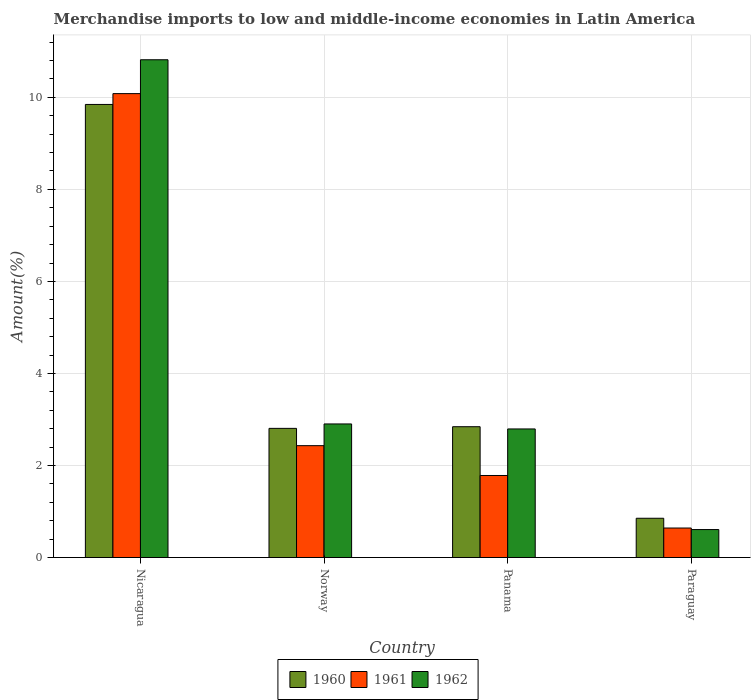How many bars are there on the 1st tick from the right?
Keep it short and to the point. 3. What is the label of the 1st group of bars from the left?
Offer a terse response. Nicaragua. What is the percentage of amount earned from merchandise imports in 1961 in Nicaragua?
Your response must be concise. 10.08. Across all countries, what is the maximum percentage of amount earned from merchandise imports in 1961?
Ensure brevity in your answer.  10.08. Across all countries, what is the minimum percentage of amount earned from merchandise imports in 1962?
Your answer should be very brief. 0.61. In which country was the percentage of amount earned from merchandise imports in 1960 maximum?
Ensure brevity in your answer.  Nicaragua. In which country was the percentage of amount earned from merchandise imports in 1960 minimum?
Your response must be concise. Paraguay. What is the total percentage of amount earned from merchandise imports in 1961 in the graph?
Offer a terse response. 14.94. What is the difference between the percentage of amount earned from merchandise imports in 1961 in Nicaragua and that in Norway?
Offer a very short reply. 7.65. What is the difference between the percentage of amount earned from merchandise imports in 1962 in Nicaragua and the percentage of amount earned from merchandise imports in 1961 in Norway?
Provide a succinct answer. 8.39. What is the average percentage of amount earned from merchandise imports in 1961 per country?
Keep it short and to the point. 3.73. What is the difference between the percentage of amount earned from merchandise imports of/in 1961 and percentage of amount earned from merchandise imports of/in 1960 in Norway?
Offer a terse response. -0.38. What is the ratio of the percentage of amount earned from merchandise imports in 1962 in Norway to that in Paraguay?
Ensure brevity in your answer.  4.78. Is the percentage of amount earned from merchandise imports in 1961 in Nicaragua less than that in Norway?
Offer a terse response. No. What is the difference between the highest and the second highest percentage of amount earned from merchandise imports in 1961?
Provide a succinct answer. -8.3. What is the difference between the highest and the lowest percentage of amount earned from merchandise imports in 1960?
Your response must be concise. 8.99. What does the 3rd bar from the left in Nicaragua represents?
Your response must be concise. 1962. Is it the case that in every country, the sum of the percentage of amount earned from merchandise imports in 1960 and percentage of amount earned from merchandise imports in 1961 is greater than the percentage of amount earned from merchandise imports in 1962?
Offer a very short reply. Yes. How many bars are there?
Provide a short and direct response. 12. How many countries are there in the graph?
Your response must be concise. 4. What is the difference between two consecutive major ticks on the Y-axis?
Your response must be concise. 2. Are the values on the major ticks of Y-axis written in scientific E-notation?
Keep it short and to the point. No. How many legend labels are there?
Make the answer very short. 3. What is the title of the graph?
Provide a short and direct response. Merchandise imports to low and middle-income economies in Latin America. What is the label or title of the X-axis?
Offer a very short reply. Country. What is the label or title of the Y-axis?
Provide a succinct answer. Amount(%). What is the Amount(%) in 1960 in Nicaragua?
Provide a succinct answer. 9.85. What is the Amount(%) of 1961 in Nicaragua?
Provide a short and direct response. 10.08. What is the Amount(%) of 1962 in Nicaragua?
Ensure brevity in your answer.  10.82. What is the Amount(%) in 1960 in Norway?
Give a very brief answer. 2.81. What is the Amount(%) of 1961 in Norway?
Your answer should be very brief. 2.43. What is the Amount(%) in 1962 in Norway?
Provide a succinct answer. 2.9. What is the Amount(%) in 1960 in Panama?
Give a very brief answer. 2.84. What is the Amount(%) in 1961 in Panama?
Provide a succinct answer. 1.78. What is the Amount(%) of 1962 in Panama?
Your answer should be compact. 2.79. What is the Amount(%) in 1960 in Paraguay?
Offer a terse response. 0.85. What is the Amount(%) in 1961 in Paraguay?
Provide a short and direct response. 0.64. What is the Amount(%) in 1962 in Paraguay?
Offer a terse response. 0.61. Across all countries, what is the maximum Amount(%) in 1960?
Provide a short and direct response. 9.85. Across all countries, what is the maximum Amount(%) in 1961?
Ensure brevity in your answer.  10.08. Across all countries, what is the maximum Amount(%) of 1962?
Ensure brevity in your answer.  10.82. Across all countries, what is the minimum Amount(%) in 1960?
Make the answer very short. 0.85. Across all countries, what is the minimum Amount(%) of 1961?
Make the answer very short. 0.64. Across all countries, what is the minimum Amount(%) in 1962?
Keep it short and to the point. 0.61. What is the total Amount(%) of 1960 in the graph?
Ensure brevity in your answer.  16.35. What is the total Amount(%) of 1961 in the graph?
Your answer should be very brief. 14.94. What is the total Amount(%) of 1962 in the graph?
Offer a terse response. 17.12. What is the difference between the Amount(%) of 1960 in Nicaragua and that in Norway?
Your response must be concise. 7.04. What is the difference between the Amount(%) in 1961 in Nicaragua and that in Norway?
Provide a succinct answer. 7.65. What is the difference between the Amount(%) in 1962 in Nicaragua and that in Norway?
Your answer should be very brief. 7.91. What is the difference between the Amount(%) of 1960 in Nicaragua and that in Panama?
Provide a succinct answer. 7. What is the difference between the Amount(%) of 1961 in Nicaragua and that in Panama?
Your response must be concise. 8.3. What is the difference between the Amount(%) of 1962 in Nicaragua and that in Panama?
Your response must be concise. 8.02. What is the difference between the Amount(%) in 1960 in Nicaragua and that in Paraguay?
Your response must be concise. 8.99. What is the difference between the Amount(%) of 1961 in Nicaragua and that in Paraguay?
Give a very brief answer. 9.44. What is the difference between the Amount(%) in 1962 in Nicaragua and that in Paraguay?
Provide a short and direct response. 10.21. What is the difference between the Amount(%) of 1960 in Norway and that in Panama?
Offer a terse response. -0.04. What is the difference between the Amount(%) in 1961 in Norway and that in Panama?
Give a very brief answer. 0.65. What is the difference between the Amount(%) in 1962 in Norway and that in Panama?
Ensure brevity in your answer.  0.11. What is the difference between the Amount(%) of 1960 in Norway and that in Paraguay?
Your response must be concise. 1.95. What is the difference between the Amount(%) in 1961 in Norway and that in Paraguay?
Keep it short and to the point. 1.79. What is the difference between the Amount(%) of 1962 in Norway and that in Paraguay?
Your answer should be very brief. 2.29. What is the difference between the Amount(%) in 1960 in Panama and that in Paraguay?
Ensure brevity in your answer.  1.99. What is the difference between the Amount(%) in 1961 in Panama and that in Paraguay?
Keep it short and to the point. 1.14. What is the difference between the Amount(%) of 1962 in Panama and that in Paraguay?
Provide a short and direct response. 2.19. What is the difference between the Amount(%) in 1960 in Nicaragua and the Amount(%) in 1961 in Norway?
Offer a terse response. 7.41. What is the difference between the Amount(%) in 1960 in Nicaragua and the Amount(%) in 1962 in Norway?
Your response must be concise. 6.94. What is the difference between the Amount(%) in 1961 in Nicaragua and the Amount(%) in 1962 in Norway?
Make the answer very short. 7.18. What is the difference between the Amount(%) of 1960 in Nicaragua and the Amount(%) of 1961 in Panama?
Offer a terse response. 8.06. What is the difference between the Amount(%) in 1960 in Nicaragua and the Amount(%) in 1962 in Panama?
Give a very brief answer. 7.05. What is the difference between the Amount(%) of 1961 in Nicaragua and the Amount(%) of 1962 in Panama?
Your response must be concise. 7.29. What is the difference between the Amount(%) in 1960 in Nicaragua and the Amount(%) in 1961 in Paraguay?
Your answer should be compact. 9.2. What is the difference between the Amount(%) in 1960 in Nicaragua and the Amount(%) in 1962 in Paraguay?
Keep it short and to the point. 9.24. What is the difference between the Amount(%) of 1961 in Nicaragua and the Amount(%) of 1962 in Paraguay?
Make the answer very short. 9.47. What is the difference between the Amount(%) in 1960 in Norway and the Amount(%) in 1961 in Panama?
Your answer should be very brief. 1.02. What is the difference between the Amount(%) in 1960 in Norway and the Amount(%) in 1962 in Panama?
Your response must be concise. 0.01. What is the difference between the Amount(%) of 1961 in Norway and the Amount(%) of 1962 in Panama?
Your answer should be compact. -0.36. What is the difference between the Amount(%) in 1960 in Norway and the Amount(%) in 1961 in Paraguay?
Provide a short and direct response. 2.17. What is the difference between the Amount(%) of 1960 in Norway and the Amount(%) of 1962 in Paraguay?
Make the answer very short. 2.2. What is the difference between the Amount(%) in 1961 in Norway and the Amount(%) in 1962 in Paraguay?
Give a very brief answer. 1.82. What is the difference between the Amount(%) in 1960 in Panama and the Amount(%) in 1961 in Paraguay?
Offer a terse response. 2.2. What is the difference between the Amount(%) of 1960 in Panama and the Amount(%) of 1962 in Paraguay?
Provide a short and direct response. 2.23. What is the difference between the Amount(%) of 1961 in Panama and the Amount(%) of 1962 in Paraguay?
Offer a very short reply. 1.17. What is the average Amount(%) of 1960 per country?
Provide a short and direct response. 4.09. What is the average Amount(%) in 1961 per country?
Give a very brief answer. 3.73. What is the average Amount(%) of 1962 per country?
Offer a terse response. 4.28. What is the difference between the Amount(%) in 1960 and Amount(%) in 1961 in Nicaragua?
Keep it short and to the point. -0.24. What is the difference between the Amount(%) in 1960 and Amount(%) in 1962 in Nicaragua?
Provide a short and direct response. -0.97. What is the difference between the Amount(%) in 1961 and Amount(%) in 1962 in Nicaragua?
Your answer should be very brief. -0.74. What is the difference between the Amount(%) of 1960 and Amount(%) of 1961 in Norway?
Give a very brief answer. 0.38. What is the difference between the Amount(%) in 1960 and Amount(%) in 1962 in Norway?
Your answer should be very brief. -0.1. What is the difference between the Amount(%) in 1961 and Amount(%) in 1962 in Norway?
Offer a very short reply. -0.47. What is the difference between the Amount(%) in 1960 and Amount(%) in 1961 in Panama?
Your answer should be very brief. 1.06. What is the difference between the Amount(%) in 1960 and Amount(%) in 1962 in Panama?
Give a very brief answer. 0.05. What is the difference between the Amount(%) in 1961 and Amount(%) in 1962 in Panama?
Offer a very short reply. -1.01. What is the difference between the Amount(%) in 1960 and Amount(%) in 1961 in Paraguay?
Offer a very short reply. 0.21. What is the difference between the Amount(%) in 1960 and Amount(%) in 1962 in Paraguay?
Give a very brief answer. 0.25. What is the difference between the Amount(%) of 1961 and Amount(%) of 1962 in Paraguay?
Your answer should be compact. 0.03. What is the ratio of the Amount(%) of 1960 in Nicaragua to that in Norway?
Your answer should be compact. 3.51. What is the ratio of the Amount(%) of 1961 in Nicaragua to that in Norway?
Your answer should be compact. 4.15. What is the ratio of the Amount(%) in 1962 in Nicaragua to that in Norway?
Keep it short and to the point. 3.73. What is the ratio of the Amount(%) of 1960 in Nicaragua to that in Panama?
Make the answer very short. 3.46. What is the ratio of the Amount(%) in 1961 in Nicaragua to that in Panama?
Provide a succinct answer. 5.66. What is the ratio of the Amount(%) in 1962 in Nicaragua to that in Panama?
Provide a succinct answer. 3.87. What is the ratio of the Amount(%) of 1960 in Nicaragua to that in Paraguay?
Keep it short and to the point. 11.54. What is the ratio of the Amount(%) of 1961 in Nicaragua to that in Paraguay?
Make the answer very short. 15.72. What is the ratio of the Amount(%) of 1962 in Nicaragua to that in Paraguay?
Your response must be concise. 17.8. What is the ratio of the Amount(%) in 1960 in Norway to that in Panama?
Offer a terse response. 0.99. What is the ratio of the Amount(%) in 1961 in Norway to that in Panama?
Keep it short and to the point. 1.36. What is the ratio of the Amount(%) in 1962 in Norway to that in Panama?
Your answer should be compact. 1.04. What is the ratio of the Amount(%) of 1960 in Norway to that in Paraguay?
Give a very brief answer. 3.29. What is the ratio of the Amount(%) of 1961 in Norway to that in Paraguay?
Keep it short and to the point. 3.79. What is the ratio of the Amount(%) of 1962 in Norway to that in Paraguay?
Provide a short and direct response. 4.78. What is the ratio of the Amount(%) of 1960 in Panama to that in Paraguay?
Your answer should be very brief. 3.33. What is the ratio of the Amount(%) in 1961 in Panama to that in Paraguay?
Your answer should be compact. 2.78. What is the ratio of the Amount(%) in 1962 in Panama to that in Paraguay?
Provide a succinct answer. 4.6. What is the difference between the highest and the second highest Amount(%) in 1960?
Your response must be concise. 7. What is the difference between the highest and the second highest Amount(%) of 1961?
Ensure brevity in your answer.  7.65. What is the difference between the highest and the second highest Amount(%) in 1962?
Your answer should be very brief. 7.91. What is the difference between the highest and the lowest Amount(%) of 1960?
Provide a succinct answer. 8.99. What is the difference between the highest and the lowest Amount(%) in 1961?
Your answer should be very brief. 9.44. What is the difference between the highest and the lowest Amount(%) of 1962?
Provide a short and direct response. 10.21. 